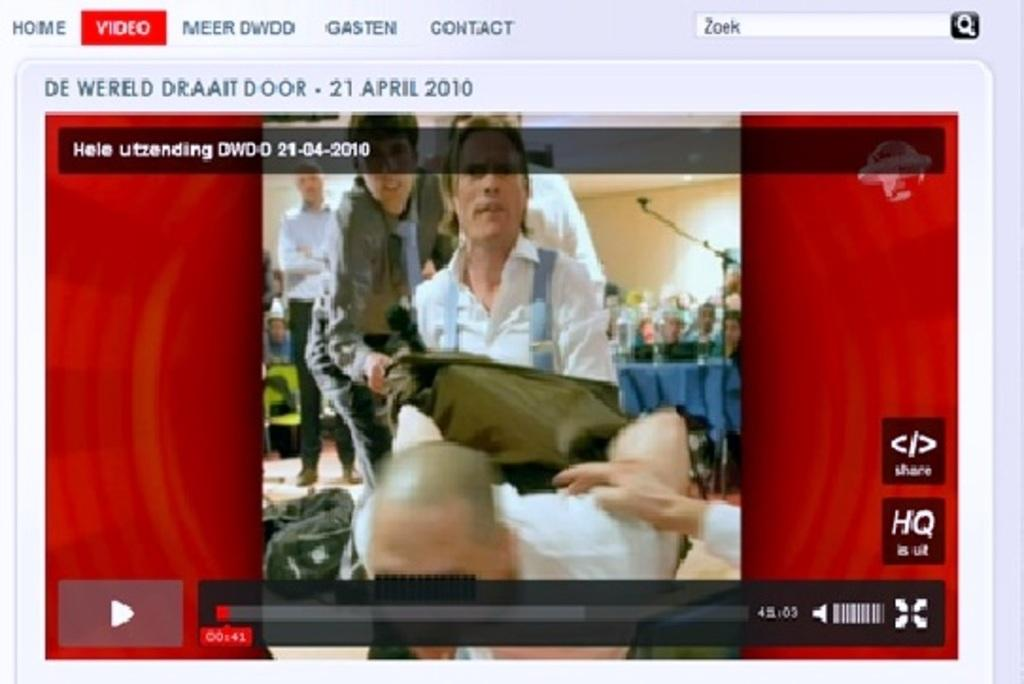Provide a one-sentence caption for the provided image. A computer window shows a red tab with "video" on it. 